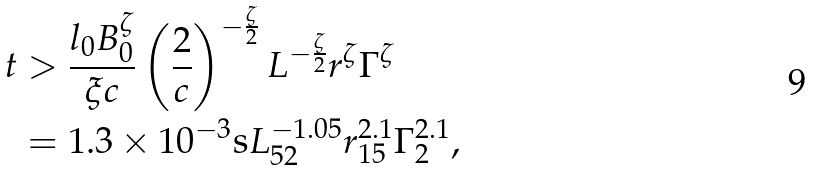<formula> <loc_0><loc_0><loc_500><loc_500>t & > \frac { l _ { 0 } B _ { 0 } ^ { \zeta } } { \xi c } \left ( \frac { 2 } { c } \right ) ^ { - \frac { \zeta } { 2 } } L ^ { - \frac { \zeta } { 2 } } r ^ { \zeta } \Gamma ^ { \zeta } \\ & = 1 . 3 \times 1 0 ^ { - 3 } \text {s} L _ { 5 2 } ^ { - 1 . 0 5 } r _ { 1 5 } ^ { 2 . 1 } \Gamma _ { 2 } ^ { 2 . 1 } ,</formula> 